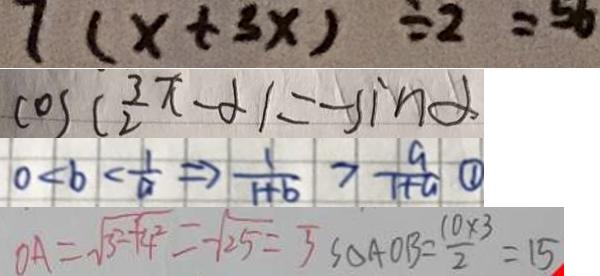<formula> <loc_0><loc_0><loc_500><loc_500>7 ( x + 3 x ) \div 2 = 5 6 
 \cos ( \frac { 3 \pi } { 2 } - \alpha ) = - \sin \alpha 
 0 < b < \frac { 1 } { a } \Rightarrow \frac { 1 } { 1 + b } > \frac { a } { 1 + a } \textcircled { 1 } 
 O A = \sqrt { 3 ^ { 2 } + 4 ^ { 2 } } = \sqrt { 2 5 } = 5 S _ { \Delta A O B } = \frac { 1 0 \times 3 } { 2 } = 1 5</formula> 